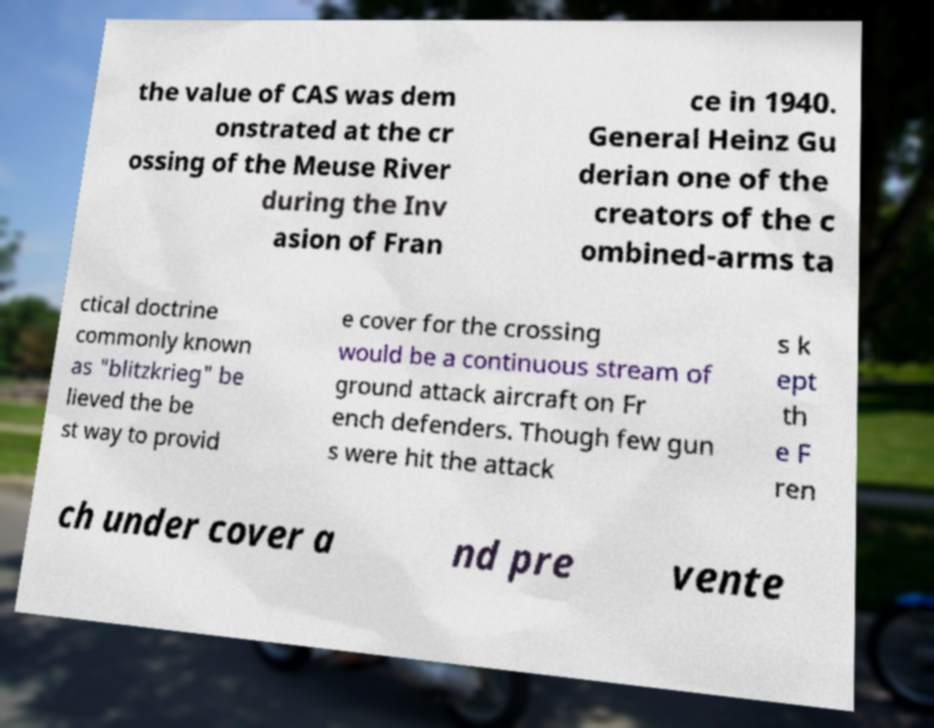For documentation purposes, I need the text within this image transcribed. Could you provide that? the value of CAS was dem onstrated at the cr ossing of the Meuse River during the Inv asion of Fran ce in 1940. General Heinz Gu derian one of the creators of the c ombined-arms ta ctical doctrine commonly known as "blitzkrieg" be lieved the be st way to provid e cover for the crossing would be a continuous stream of ground attack aircraft on Fr ench defenders. Though few gun s were hit the attack s k ept th e F ren ch under cover a nd pre vente 